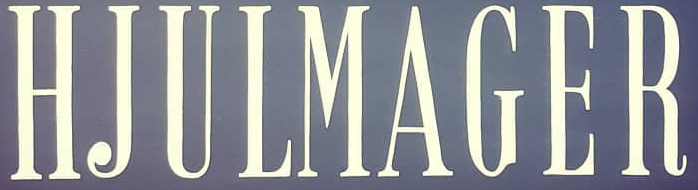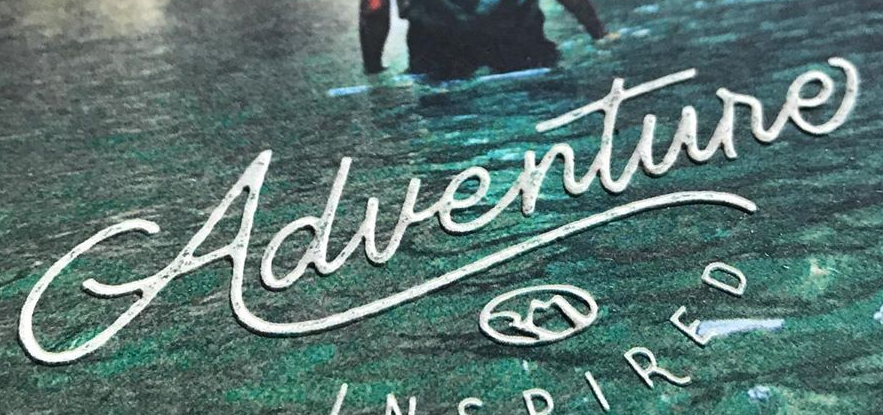What words are shown in these images in order, separated by a semicolon? HJULMAGER; Adventure 